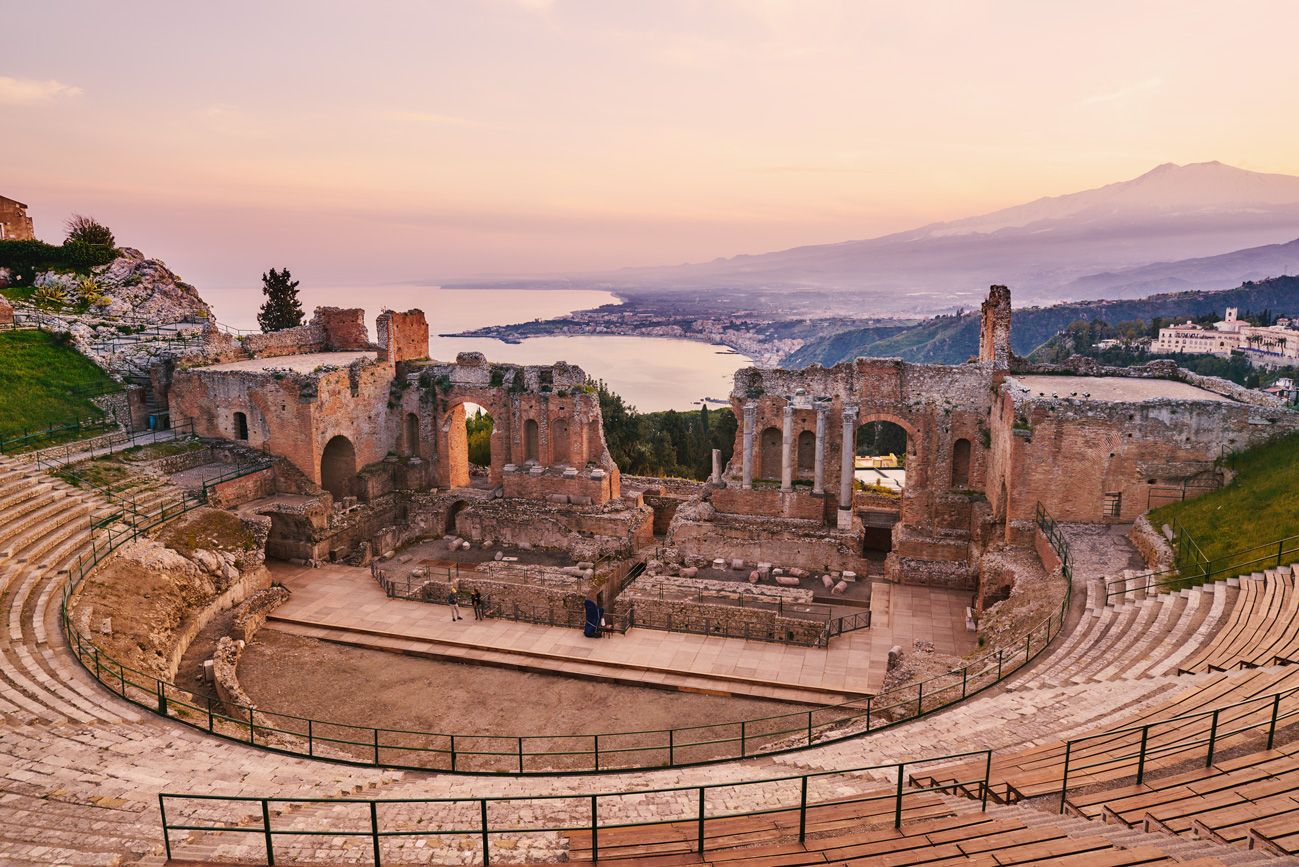Why was the theater built in this particular location? The ancient Greeks show a keen eye for aesthetics and acoustics when they built theaters. The location in Taormina was chosen for its incredible natural acoustics and also for the panoramic views it offered of the Mediterranean and Mount Etna. The position on the hillside allowed for the congregation of large crowds while ensuring everyone had a clear view of the performances. Moreover, public buildings like this theater were often situated at high points in Greek cities as a statement of prestige and importance. 